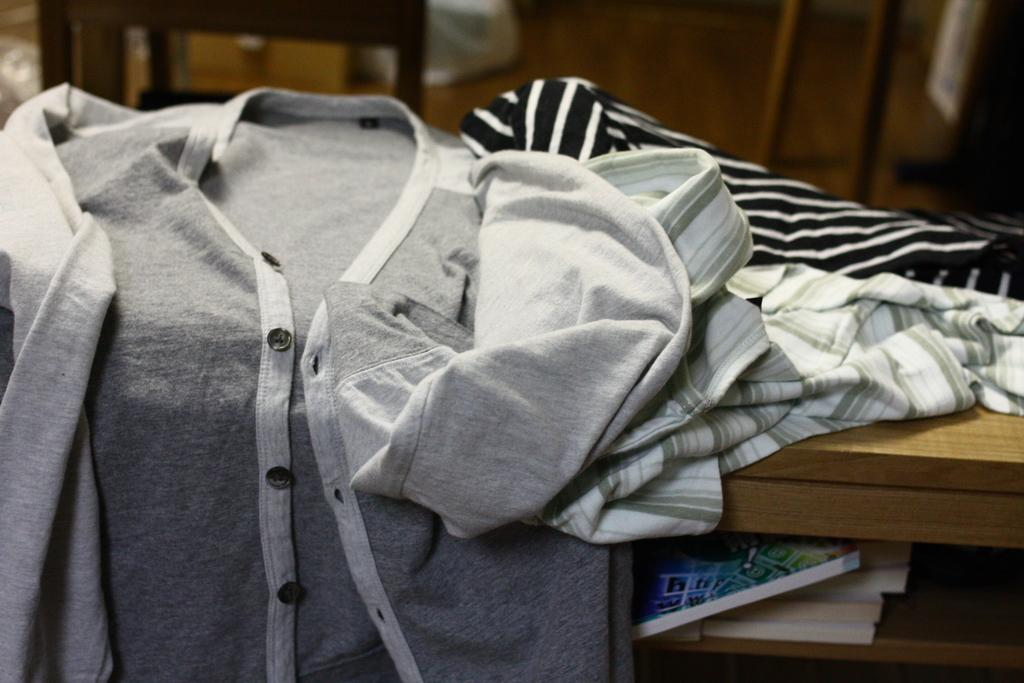What is placed on the brown color surface in the image? There are clothes on a brown color surface in the image. What can be found inside the brown color shelf? There are books inside a brown color shelf in the image. Can you describe the background of the image? The background of the image is blurred. How many zebras can be seen grazing in the background of the image? There are no zebras present in the image; the background is blurred. What type of bears are sitting on the clothes in the image? There are no bears present in the image; there are only clothes on the brown color surface. 